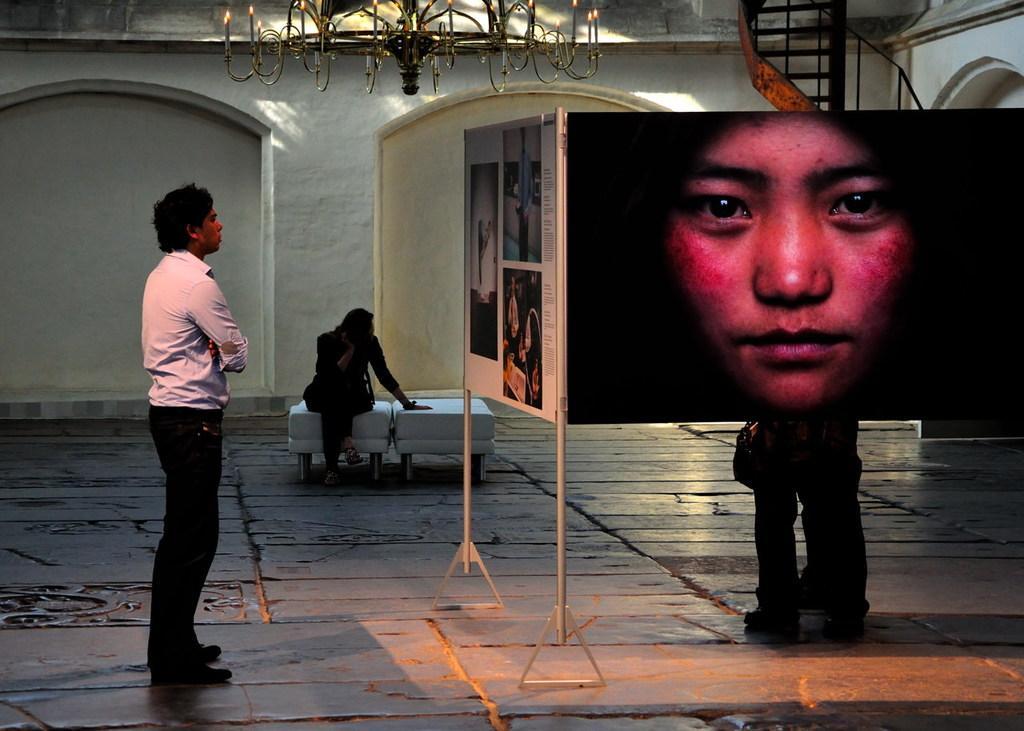Please provide a concise description of this image. In this image we can see a person standing on the floor looking at the pictures placed on the stand. We can also see a person sitting on the chair. On the backside we can see a wall, stairs and a ceiling light. 